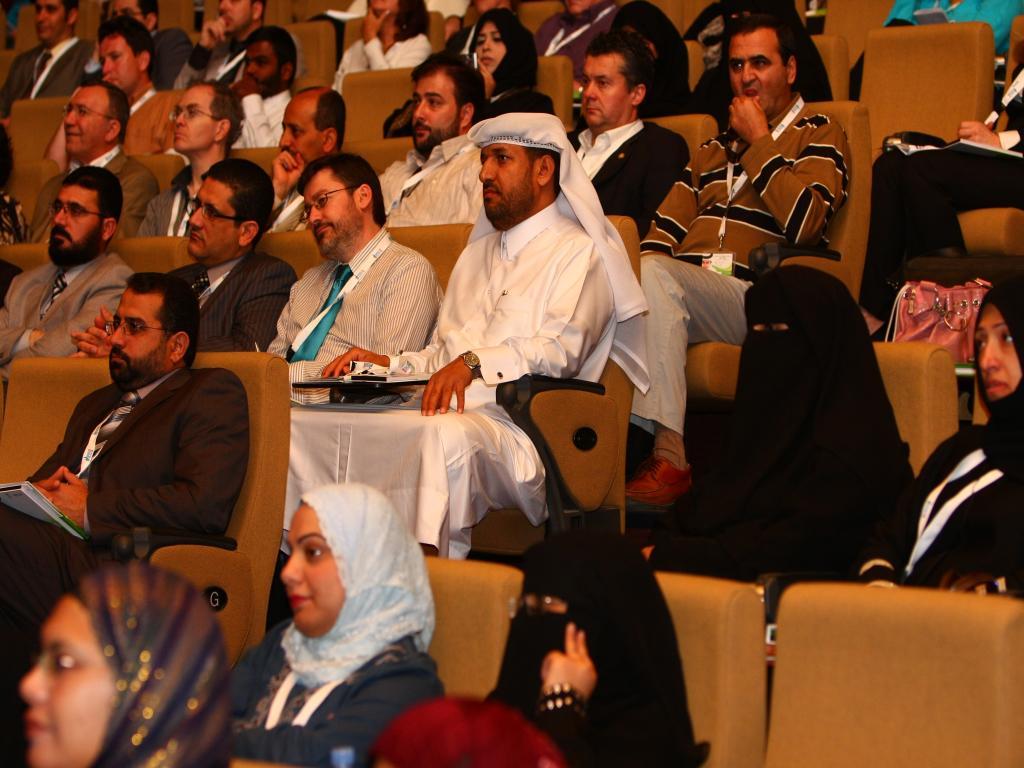Please provide a concise description of this image. In this image, there are a few people sitting on chairs. 